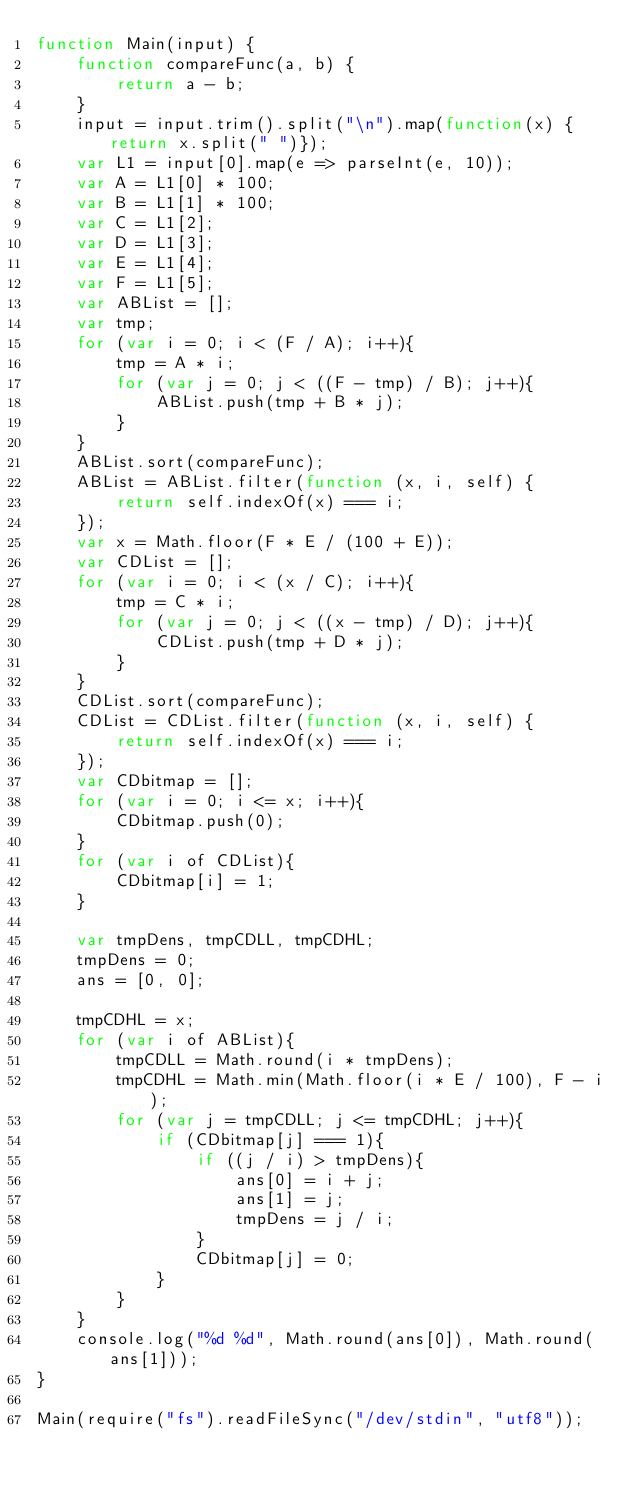Convert code to text. <code><loc_0><loc_0><loc_500><loc_500><_JavaScript_>function Main(input) {
	function compareFunc(a, b) {
		return a - b;
	}
	input = input.trim().split("\n").map(function(x) { return x.split(" ")});
	var L1 = input[0].map(e => parseInt(e, 10));
	var A = L1[0] * 100;
	var B = L1[1] * 100;
	var C = L1[2];
	var D = L1[3];
	var E = L1[4];
	var F = L1[5];
	var ABList = [];
	var tmp;
	for (var i = 0; i < (F / A); i++){
		tmp = A * i;
		for (var j = 0; j < ((F - tmp) / B); j++){
			ABList.push(tmp + B * j);
		}
	}
	ABList.sort(compareFunc);
	ABList = ABList.filter(function (x, i, self) {
		return self.indexOf(x) === i;
	});
	var x = Math.floor(F * E / (100 + E));
	var CDList = [];
	for (var i = 0; i < (x / C); i++){
		tmp = C * i;
		for (var j = 0; j < ((x - tmp) / D); j++){
			CDList.push(tmp + D * j);
		}
	}
	CDList.sort(compareFunc);
	CDList = CDList.filter(function (x, i, self) {
		return self.indexOf(x) === i;
	});
	var CDbitmap = [];
	for (var i = 0; i <= x; i++){
		CDbitmap.push(0);
	}
	for (var i of CDList){
		CDbitmap[i] = 1;
	}

	var tmpDens, tmpCDLL, tmpCDHL;
	tmpDens = 0;
	ans = [0, 0];
	
	tmpCDHL = x;
	for (var i of ABList){
		tmpCDLL = Math.round(i * tmpDens);
		tmpCDHL = Math.min(Math.floor(i * E / 100), F - i);
		for (var j = tmpCDLL; j <= tmpCDHL; j++){
			if (CDbitmap[j] === 1){
				if ((j / i) > tmpDens){
					ans[0] = i + j;
					ans[1] = j;
					tmpDens = j / i;
				}
				CDbitmap[j] = 0;
			}
		}
	}
	console.log("%d %d", Math.round(ans[0]), Math.round(ans[1]));
}

Main(require("fs").readFileSync("/dev/stdin", "utf8")); </code> 